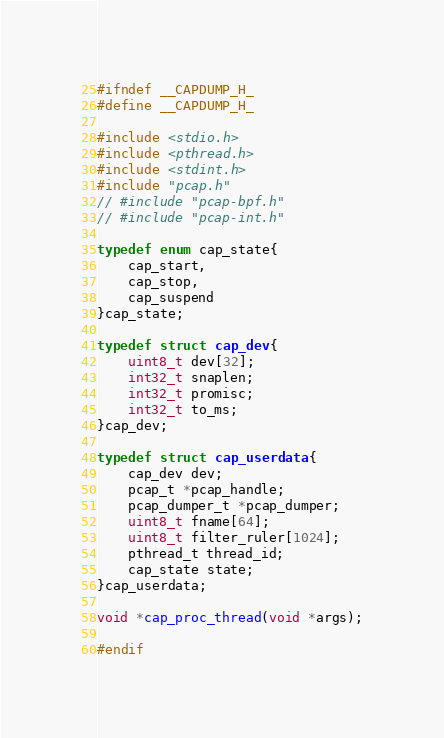<code> <loc_0><loc_0><loc_500><loc_500><_C_>#ifndef __CAPDUMP_H_
#define __CAPDUMP_H_

#include <stdio.h>
#include <pthread.h>
#include <stdint.h>
#include "pcap.h"
// #include "pcap-bpf.h"
// #include "pcap-int.h"

typedef enum cap_state{
    cap_start,
    cap_stop,
    cap_suspend
}cap_state;

typedef struct cap_dev{
    uint8_t dev[32];
    int32_t snaplen;
    int32_t promisc;
    int32_t to_ms;
}cap_dev;

typedef struct cap_userdata{
    cap_dev dev;
    pcap_t *pcap_handle;
    pcap_dumper_t *pcap_dumper;
    uint8_t fname[64];
    uint8_t filter_ruler[1024];
    pthread_t thread_id;
    cap_state state;
}cap_userdata;

void *cap_proc_thread(void *args);

#endif</code> 